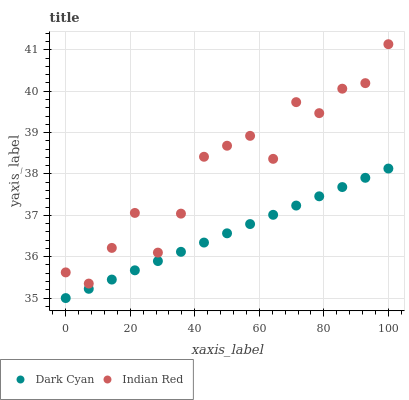Does Dark Cyan have the minimum area under the curve?
Answer yes or no. Yes. Does Indian Red have the maximum area under the curve?
Answer yes or no. Yes. Does Indian Red have the minimum area under the curve?
Answer yes or no. No. Is Dark Cyan the smoothest?
Answer yes or no. Yes. Is Indian Red the roughest?
Answer yes or no. Yes. Is Indian Red the smoothest?
Answer yes or no. No. Does Dark Cyan have the lowest value?
Answer yes or no. Yes. Does Indian Red have the lowest value?
Answer yes or no. No. Does Indian Red have the highest value?
Answer yes or no. Yes. Is Dark Cyan less than Indian Red?
Answer yes or no. Yes. Is Indian Red greater than Dark Cyan?
Answer yes or no. Yes. Does Dark Cyan intersect Indian Red?
Answer yes or no. No. 